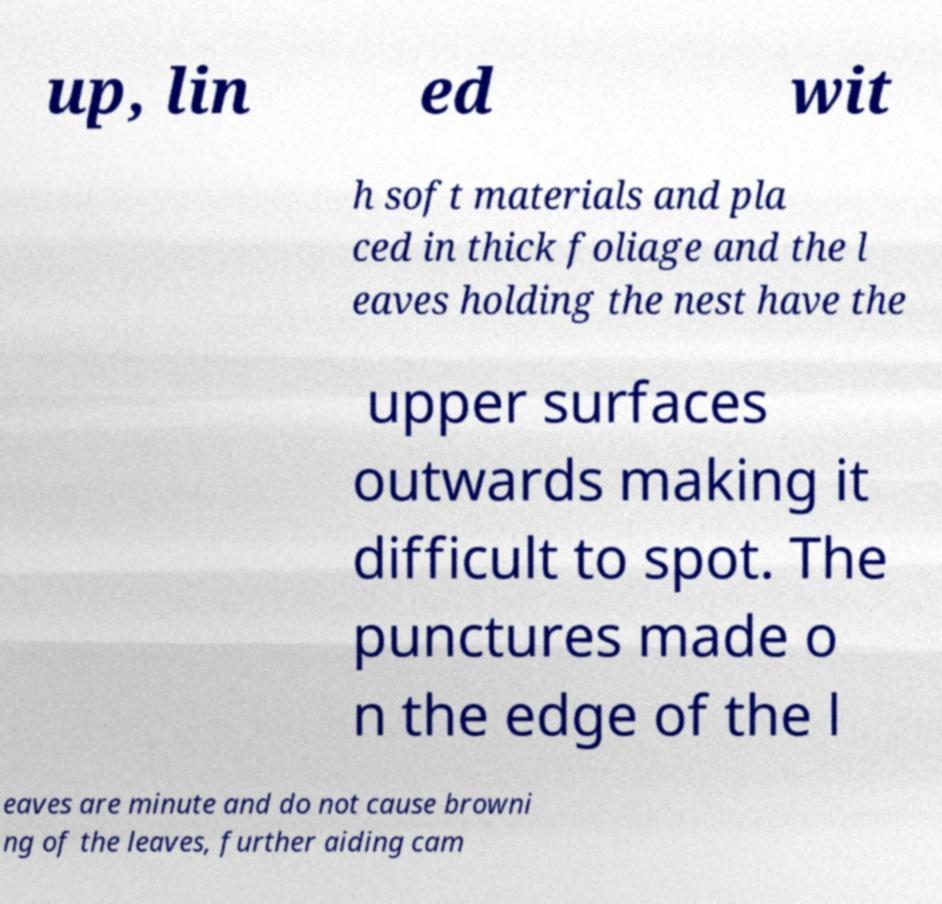What messages or text are displayed in this image? I need them in a readable, typed format. up, lin ed wit h soft materials and pla ced in thick foliage and the l eaves holding the nest have the upper surfaces outwards making it difficult to spot. The punctures made o n the edge of the l eaves are minute and do not cause browni ng of the leaves, further aiding cam 